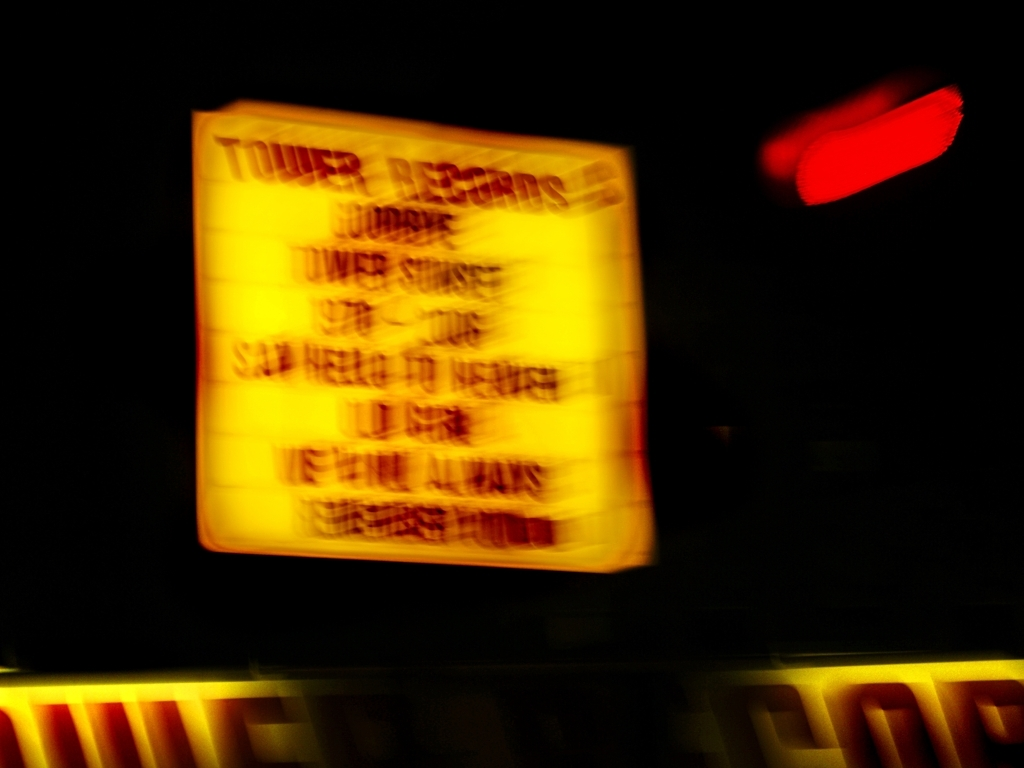Are there any quality issues with this image? Yes, the image exhibits a significant blur, suggesting either motion during the capture or a focus issue, which impacts the clarity of details. The content of the sign is not legible, and the colors are not accurately represented due to the blur. 